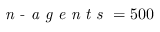<formula> <loc_0><loc_0><loc_500><loc_500>n - a g e n t s = 5 0 0</formula> 